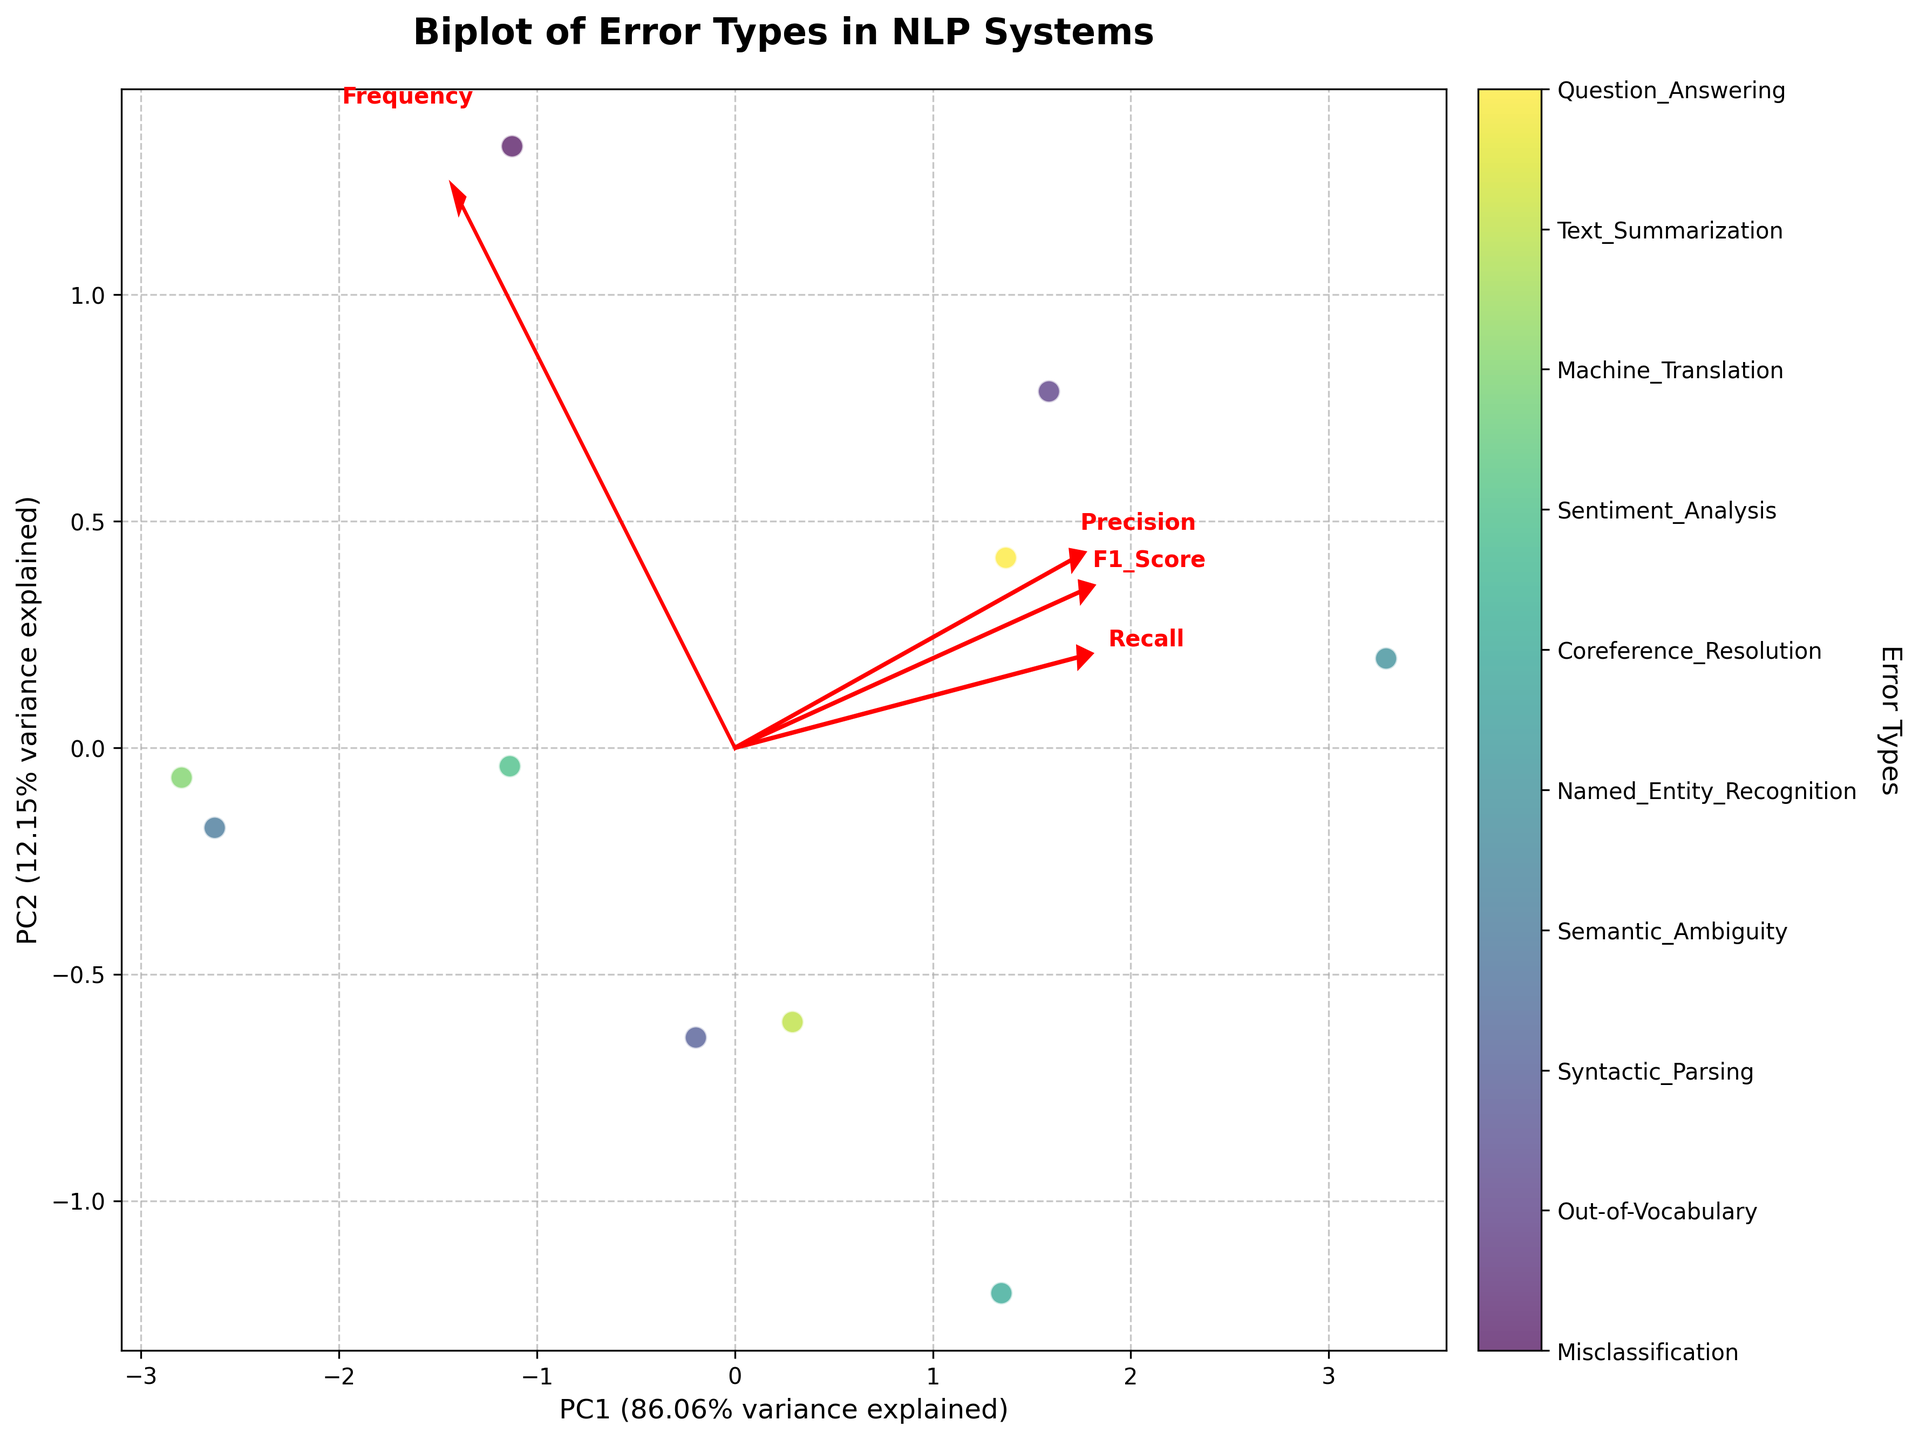What is the title of the figure? The title is usually in a prominent position at the top of the plot. In this case, it's written in the specified style settings of the plot.
Answer: Biplot of Error Types in NLP Systems What do the X and Y axes represent? Axis labels clarify what the dimensions in the plot represent. They are usually found alongside the axes themselves. In this case, PC1 and PC2 represent principal component 1 and principal component 2, accounting for the most variance in the data.
Answer: PC1 and PC2 How many error types are represented in the plot? Each unique data point corresponds to an error type. The color bar also indicates the number of unique labels. Here, we can see 10 different unique labels.
Answer: 10 Which error type has the highest frequency? The position of each colored point relates to the value of the frequency, and the points are annotated. We see "Misclassification" having the highest frequency.
Answer: Misclassification What is indicated by the red arrows in the plot? Red arrows usually denote the direction and the weight of original variables in principal components. Here they are labeled by variables 'Frequency,' 'Precision,' 'Recall,' and 'F1_Score.'
Answer: Loadings of variables Which variable has the largest influence on the first principal component (PC1)? By examining the red arrows' direction and length along the PC1 axis, the length of 'Frequency' is the longest, indicating it influences PC1 the most.
Answer: Frequency Which two error types are closest to each other in the plot? Closest proximity of points in the plot indicates similarity in their principal component scores. Examining the plot, "Out-of-Vocabulary" and "Question_Answering" are closest to each other.
Answer: Out-of-Vocabulary and Question_Answering Which error types fall into the lowest region of PC2? Lower proximity on the Y-axis indicates lower PC2 scores. The figure shows "Sentiment_Analysis" and "Semantic_Ambiguity" fall in the lowest region.
Answer: Sentiment_Analysis and Semantic_Ambiguity Between "Misclassification" and "Machine_Translation," which error type has a greater influence from 'Recall'? Observing the projections of arrows on the points, "Machine_Translation" has a longer projection on the arrow marked 'Recall,' indicating greater influence.
Answer: Machine_Translation How much variance in the data do PC1 and PC2 together explain? The explained variance ratio is usually mentioned along with the axis labels. Observing the plot, PC1 and PC2 together explain 100% of the variance.
Answer: 100% 